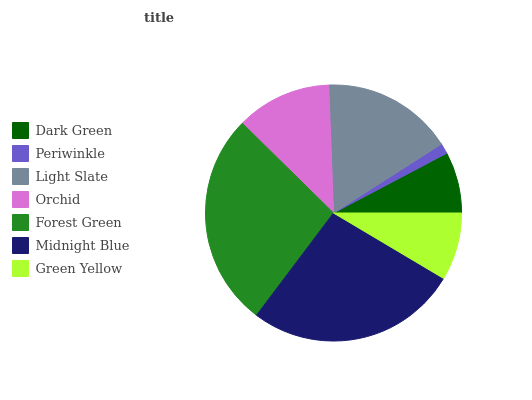Is Periwinkle the minimum?
Answer yes or no. Yes. Is Forest Green the maximum?
Answer yes or no. Yes. Is Light Slate the minimum?
Answer yes or no. No. Is Light Slate the maximum?
Answer yes or no. No. Is Light Slate greater than Periwinkle?
Answer yes or no. Yes. Is Periwinkle less than Light Slate?
Answer yes or no. Yes. Is Periwinkle greater than Light Slate?
Answer yes or no. No. Is Light Slate less than Periwinkle?
Answer yes or no. No. Is Orchid the high median?
Answer yes or no. Yes. Is Orchid the low median?
Answer yes or no. Yes. Is Midnight Blue the high median?
Answer yes or no. No. Is Periwinkle the low median?
Answer yes or no. No. 